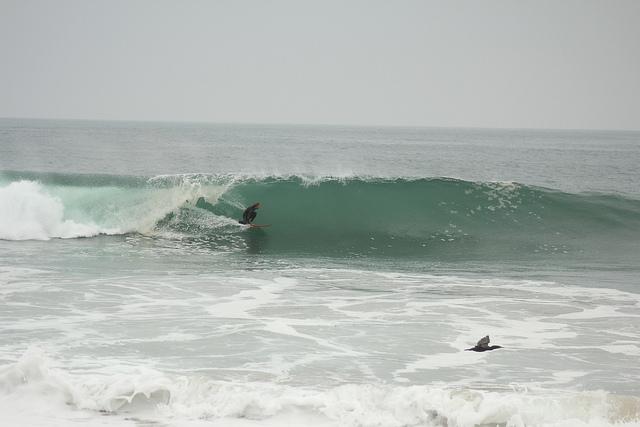Where is the surfer located?
Write a very short answer. Wave. Is there a surfer in the water?
Concise answer only. Yes. Is there a bird in the picture?
Concise answer only. Yes. Are there rocks in the water?
Quick response, please. No. What sport is he doing?
Quick response, please. Surfing. Is the surfing in the ocean?
Short answer required. Yes. Is there a shark in the water?
Give a very brief answer. No. 